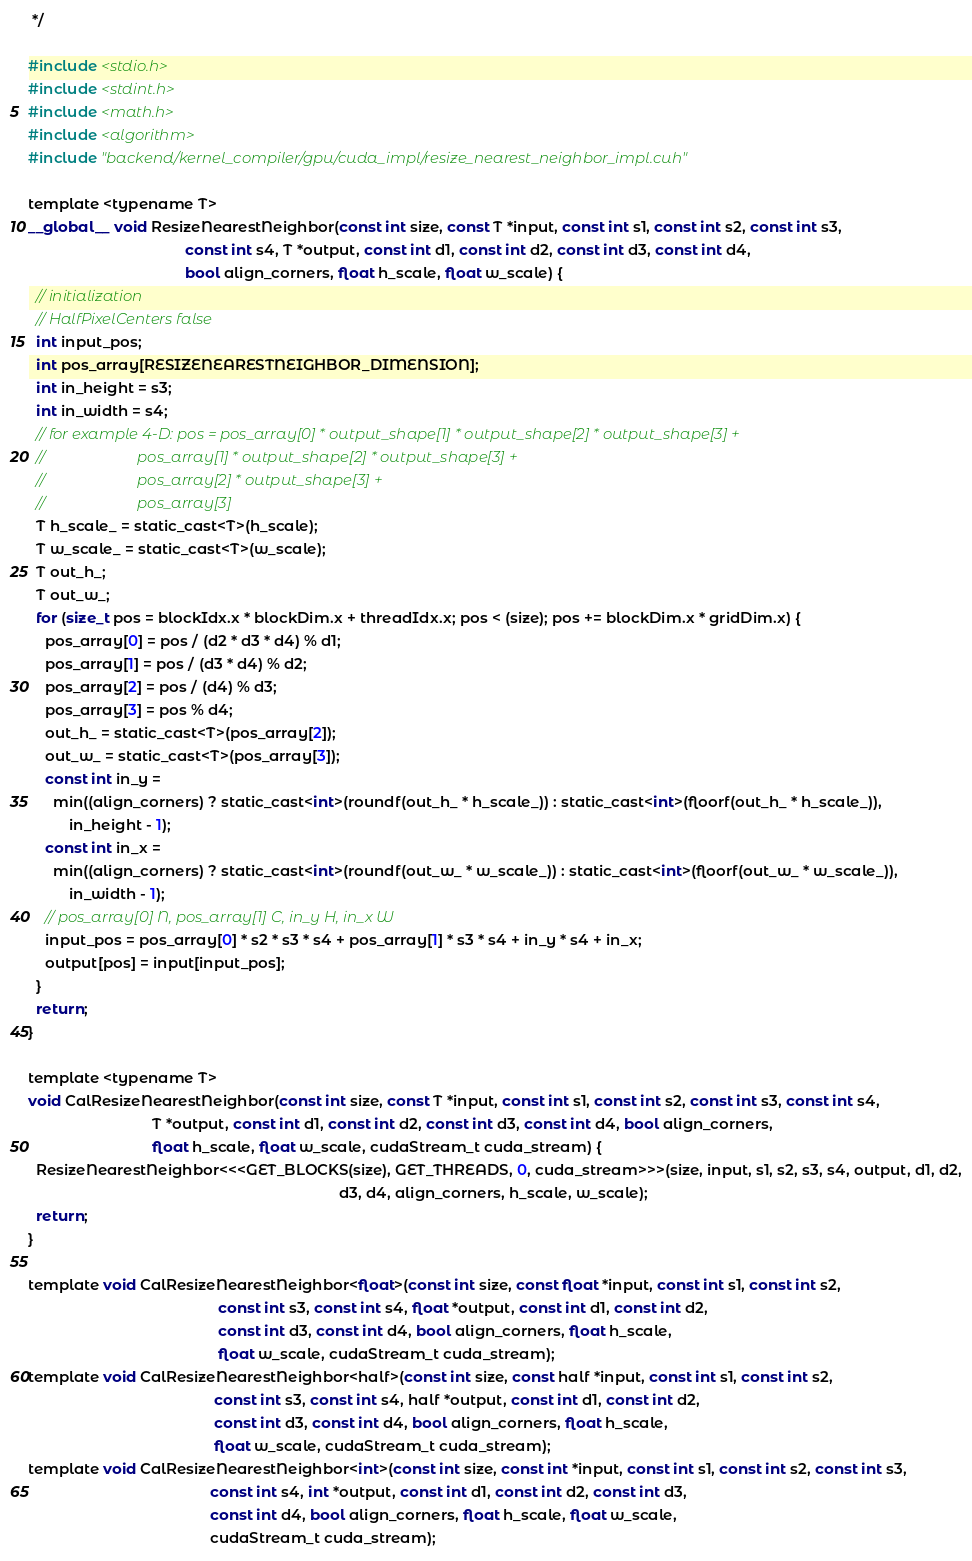<code> <loc_0><loc_0><loc_500><loc_500><_Cuda_> */

#include <stdio.h>
#include <stdint.h>
#include <math.h>
#include <algorithm>
#include "backend/kernel_compiler/gpu/cuda_impl/resize_nearest_neighbor_impl.cuh"

template <typename T>
__global__ void ResizeNearestNeighbor(const int size, const T *input, const int s1, const int s2, const int s3,
                                      const int s4, T *output, const int d1, const int d2, const int d3, const int d4,
                                      bool align_corners, float h_scale, float w_scale) {
  // initialization
  // HalfPixelCenters false
  int input_pos;
  int pos_array[RESIZENEARESTNEIGHBOR_DIMENSION];
  int in_height = s3;
  int in_width = s4;
  // for example 4-D: pos = pos_array[0] * output_shape[1] * output_shape[2] * output_shape[3] +
  //                        pos_array[1] * output_shape[2] * output_shape[3] +
  //                        pos_array[2] * output_shape[3] +
  //                        pos_array[3]
  T h_scale_ = static_cast<T>(h_scale);
  T w_scale_ = static_cast<T>(w_scale);
  T out_h_;
  T out_w_;
  for (size_t pos = blockIdx.x * blockDim.x + threadIdx.x; pos < (size); pos += blockDim.x * gridDim.x) {
    pos_array[0] = pos / (d2 * d3 * d4) % d1;
    pos_array[1] = pos / (d3 * d4) % d2;
    pos_array[2] = pos / (d4) % d3;
    pos_array[3] = pos % d4;
    out_h_ = static_cast<T>(pos_array[2]);
    out_w_ = static_cast<T>(pos_array[3]);
    const int in_y =
      min((align_corners) ? static_cast<int>(roundf(out_h_ * h_scale_)) : static_cast<int>(floorf(out_h_ * h_scale_)),
          in_height - 1);
    const int in_x =
      min((align_corners) ? static_cast<int>(roundf(out_w_ * w_scale_)) : static_cast<int>(floorf(out_w_ * w_scale_)),
          in_width - 1);
    // pos_array[0] N, pos_array[1] C, in_y H, in_x W
    input_pos = pos_array[0] * s2 * s3 * s4 + pos_array[1] * s3 * s4 + in_y * s4 + in_x;
    output[pos] = input[input_pos];
  }
  return;
}

template <typename T>
void CalResizeNearestNeighbor(const int size, const T *input, const int s1, const int s2, const int s3, const int s4,
                              T *output, const int d1, const int d2, const int d3, const int d4, bool align_corners,
                              float h_scale, float w_scale, cudaStream_t cuda_stream) {
  ResizeNearestNeighbor<<<GET_BLOCKS(size), GET_THREADS, 0, cuda_stream>>>(size, input, s1, s2, s3, s4, output, d1, d2,
                                                                           d3, d4, align_corners, h_scale, w_scale);
  return;
}

template void CalResizeNearestNeighbor<float>(const int size, const float *input, const int s1, const int s2,
                                              const int s3, const int s4, float *output, const int d1, const int d2,
                                              const int d3, const int d4, bool align_corners, float h_scale,
                                              float w_scale, cudaStream_t cuda_stream);
template void CalResizeNearestNeighbor<half>(const int size, const half *input, const int s1, const int s2,
                                             const int s3, const int s4, half *output, const int d1, const int d2,
                                             const int d3, const int d4, bool align_corners, float h_scale,
                                             float w_scale, cudaStream_t cuda_stream);
template void CalResizeNearestNeighbor<int>(const int size, const int *input, const int s1, const int s2, const int s3,
                                            const int s4, int *output, const int d1, const int d2, const int d3,
                                            const int d4, bool align_corners, float h_scale, float w_scale,
                                            cudaStream_t cuda_stream);
</code> 